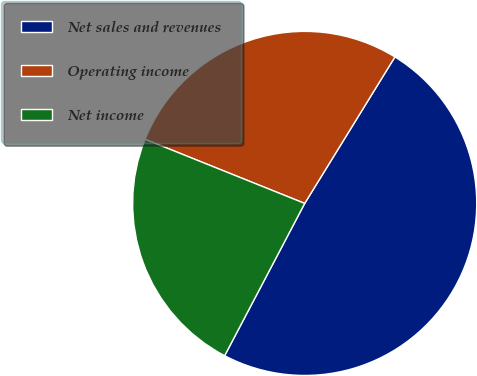Convert chart to OTSL. <chart><loc_0><loc_0><loc_500><loc_500><pie_chart><fcel>Net sales and revenues<fcel>Operating income<fcel>Net income<nl><fcel>48.92%<fcel>27.71%<fcel>23.38%<nl></chart> 